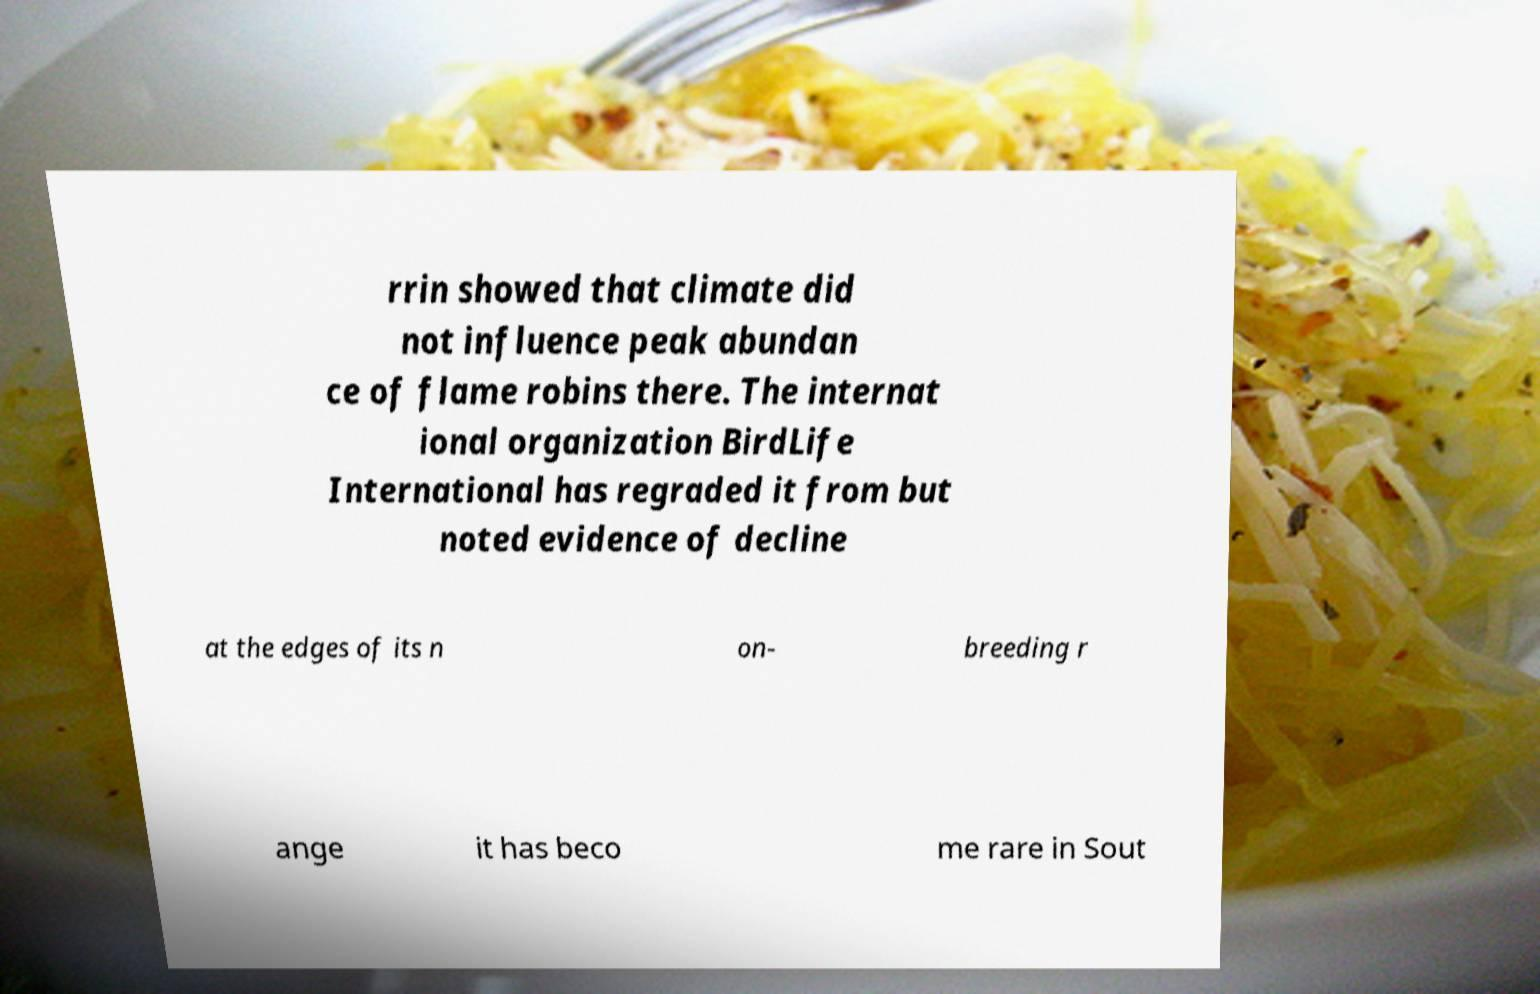Can you accurately transcribe the text from the provided image for me? rrin showed that climate did not influence peak abundan ce of flame robins there. The internat ional organization BirdLife International has regraded it from but noted evidence of decline at the edges of its n on- breeding r ange it has beco me rare in Sout 